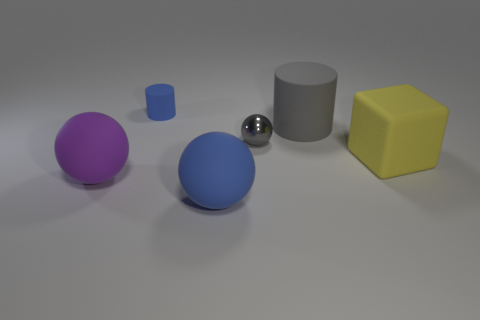What is the shape of the blue rubber object that is in front of the gray metallic object?
Give a very brief answer. Sphere. The other blue thing that is the same shape as the small metallic thing is what size?
Ensure brevity in your answer.  Large. Are there any other things that have the same size as the blue rubber ball?
Offer a terse response. Yes. What material is the gray cylinder right of the matte ball in front of the big object that is to the left of the blue cylinder?
Ensure brevity in your answer.  Rubber. Is the number of gray metallic objects that are left of the big purple rubber sphere greater than the number of small gray metallic things to the right of the large yellow object?
Your answer should be compact. No. Does the blue ball have the same size as the yellow thing?
Your answer should be very brief. Yes. There is another big matte object that is the same shape as the big blue matte thing; what is its color?
Your answer should be very brief. Purple. How many metallic things are the same color as the big block?
Provide a short and direct response. 0. Is the number of blue matte spheres to the right of the gray rubber thing greater than the number of big brown cylinders?
Give a very brief answer. No. The tiny thing that is in front of the big matte thing that is behind the gray metallic thing is what color?
Your response must be concise. Gray. 